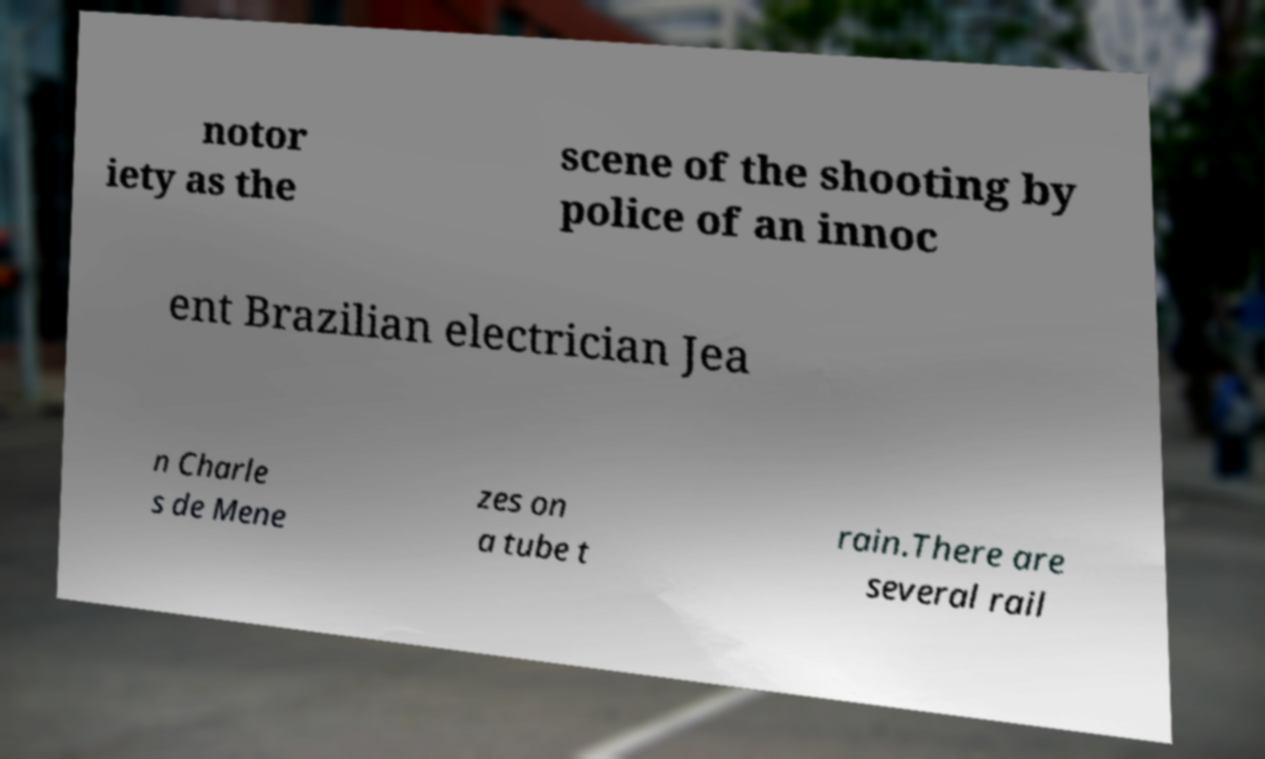What messages or text are displayed in this image? I need them in a readable, typed format. notor iety as the scene of the shooting by police of an innoc ent Brazilian electrician Jea n Charle s de Mene zes on a tube t rain.There are several rail 